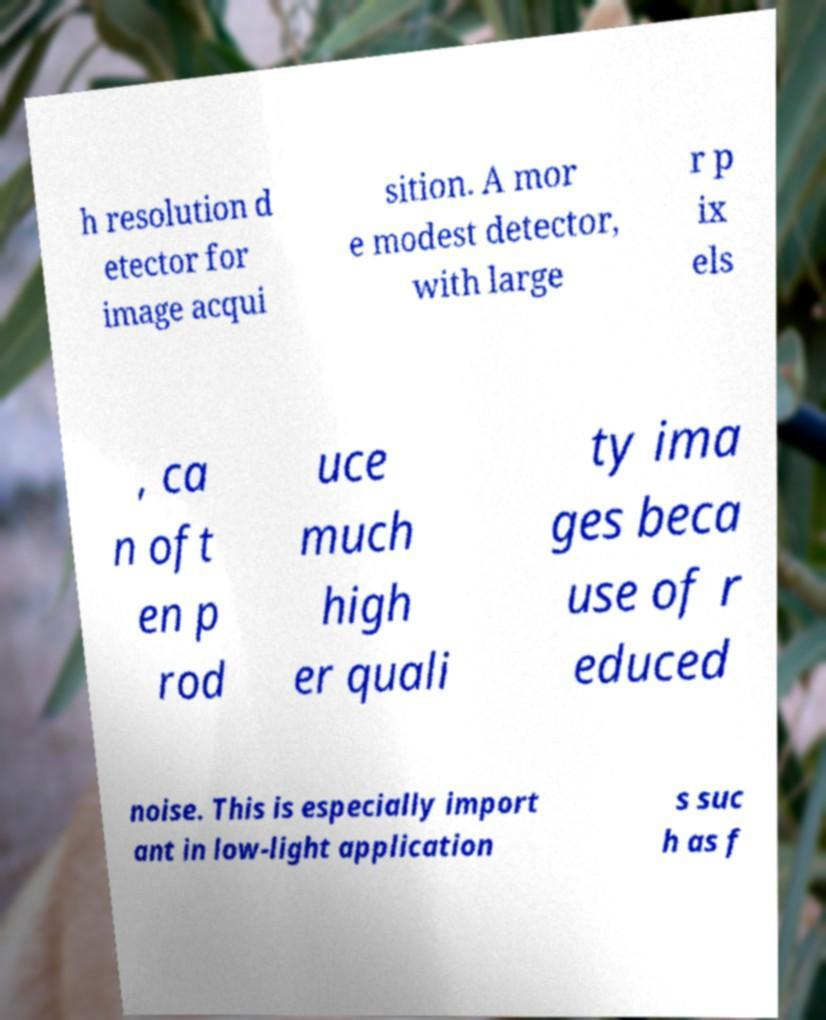Could you assist in decoding the text presented in this image and type it out clearly? h resolution d etector for image acqui sition. A mor e modest detector, with large r p ix els , ca n oft en p rod uce much high er quali ty ima ges beca use of r educed noise. This is especially import ant in low-light application s suc h as f 